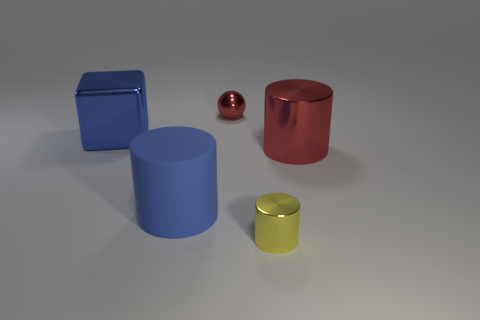Subtract all metal cylinders. How many cylinders are left? 1 Add 5 spheres. How many objects exist? 10 Subtract all yellow cylinders. How many cylinders are left? 2 Subtract all balls. How many objects are left? 4 Add 3 blue cylinders. How many blue cylinders exist? 4 Subtract 1 blue cubes. How many objects are left? 4 Subtract 2 cylinders. How many cylinders are left? 1 Subtract all purple balls. Subtract all purple cubes. How many balls are left? 1 Subtract all red metal things. Subtract all big red cylinders. How many objects are left? 2 Add 3 red shiny cylinders. How many red shiny cylinders are left? 4 